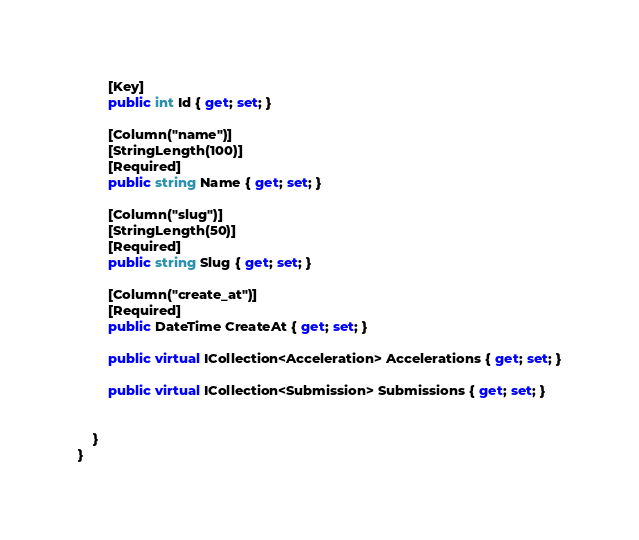Convert code to text. <code><loc_0><loc_0><loc_500><loc_500><_C#_>        [Key]
        public int Id { get; set; }

        [Column("name")]
        [StringLength(100)]
        [Required]
        public string Name { get; set; }

        [Column("slug")]
        [StringLength(50)]
        [Required]
        public string Slug { get; set; }

        [Column("create_at")]
        [Required]
        public DateTime CreateAt { get; set; }

        public virtual ICollection<Acceleration> Accelerations { get; set; }

        public virtual ICollection<Submission> Submissions { get; set; }


    }
}</code> 